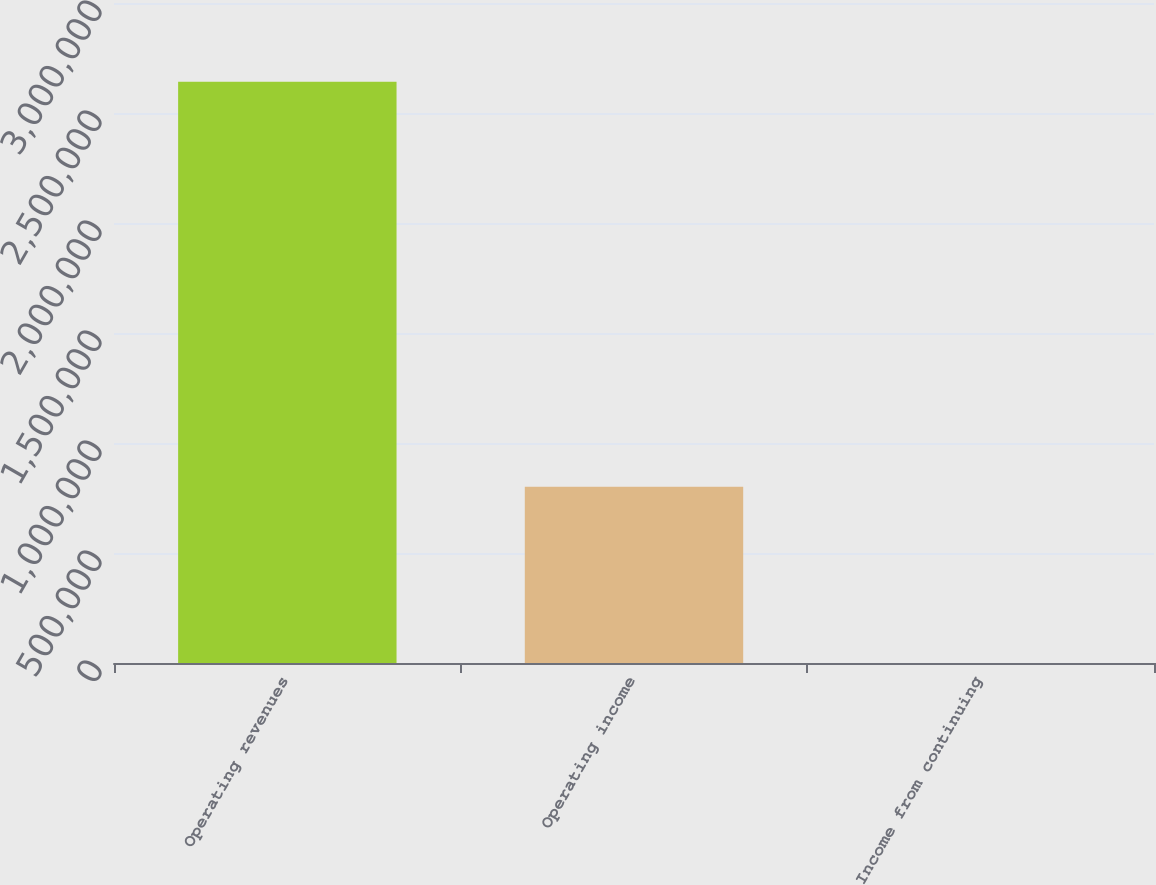Convert chart to OTSL. <chart><loc_0><loc_0><loc_500><loc_500><bar_chart><fcel>Operating revenues<fcel>Operating income<fcel>Income from continuing<nl><fcel>2.64159e+06<fcel>801639<fcel>1.72<nl></chart> 